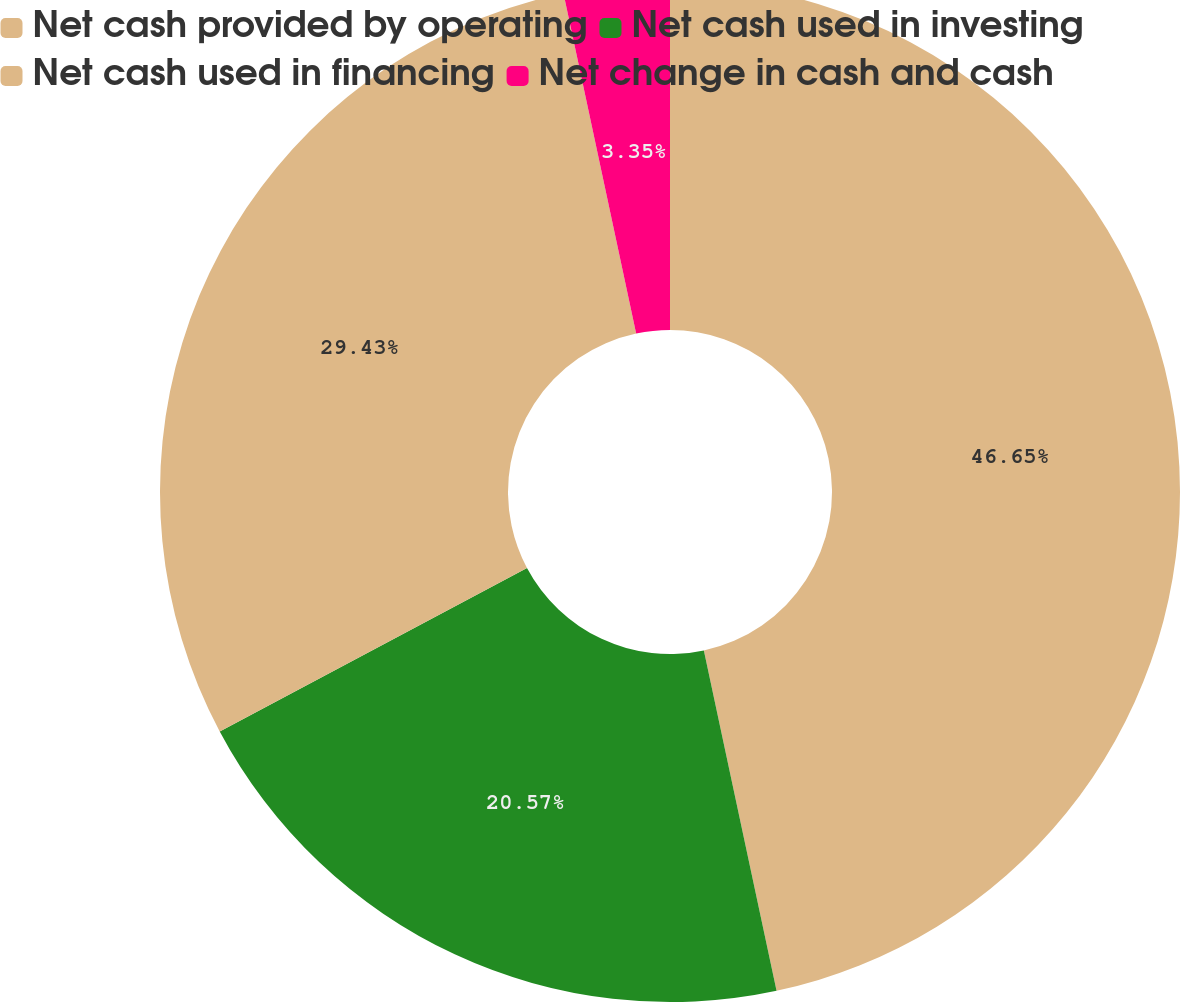Convert chart. <chart><loc_0><loc_0><loc_500><loc_500><pie_chart><fcel>Net cash provided by operating<fcel>Net cash used in investing<fcel>Net cash used in financing<fcel>Net change in cash and cash<nl><fcel>46.65%<fcel>20.57%<fcel>29.43%<fcel>3.35%<nl></chart> 